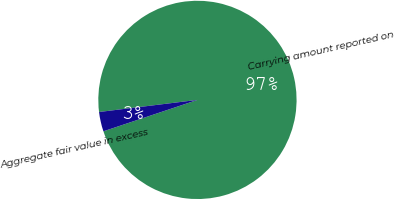<chart> <loc_0><loc_0><loc_500><loc_500><pie_chart><fcel>Carrying amount reported on<fcel>Aggregate fair value in excess<nl><fcel>96.82%<fcel>3.18%<nl></chart> 